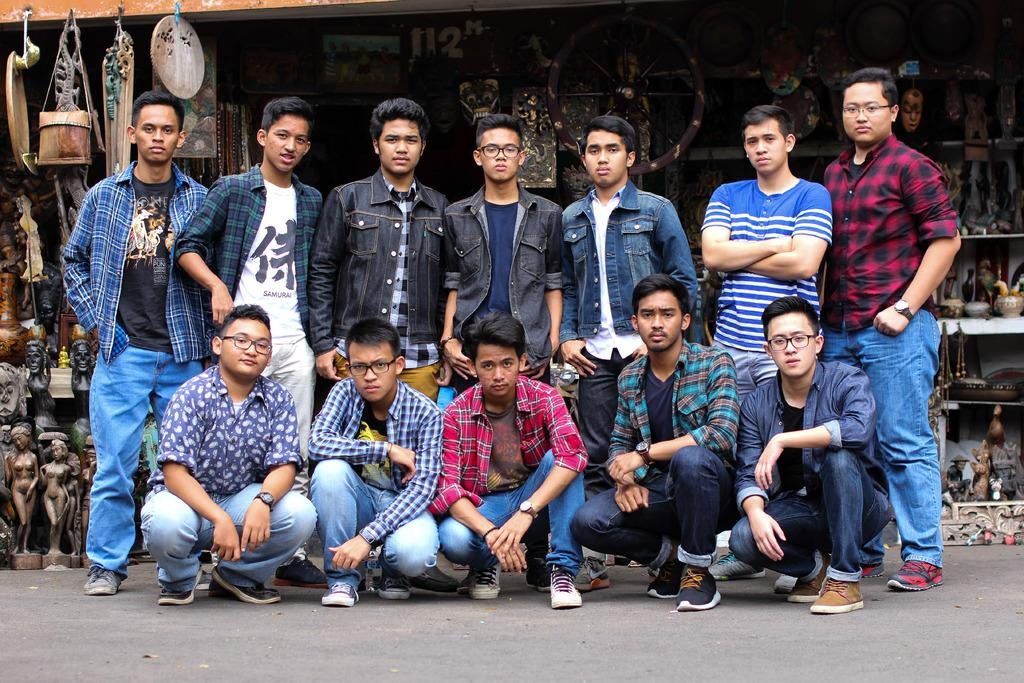What are the boys in the image doing? Some boys are standing, and some are sitting in the center of the image. Where are the boys located in relation to the image? The boys are in the center of the image. What can be seen at the bottom of the image? There is a road at the bottom of the image. What type of establishment can be seen in the background of the image? There is a store of statues and sculptures in the background of the image. How many horses are present in the image? There are no horses visible in the image. What type of bun is being served at the store of statues and sculptures in the image? There is no bun present in the image, and the store of statues and sculptures does not serve food. 